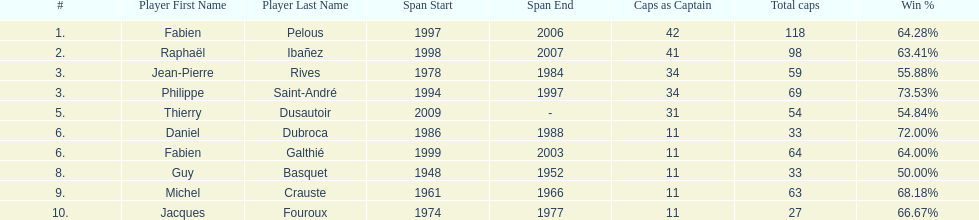Only player to serve as captain from 1998-2007 Raphaël Ibañez. 